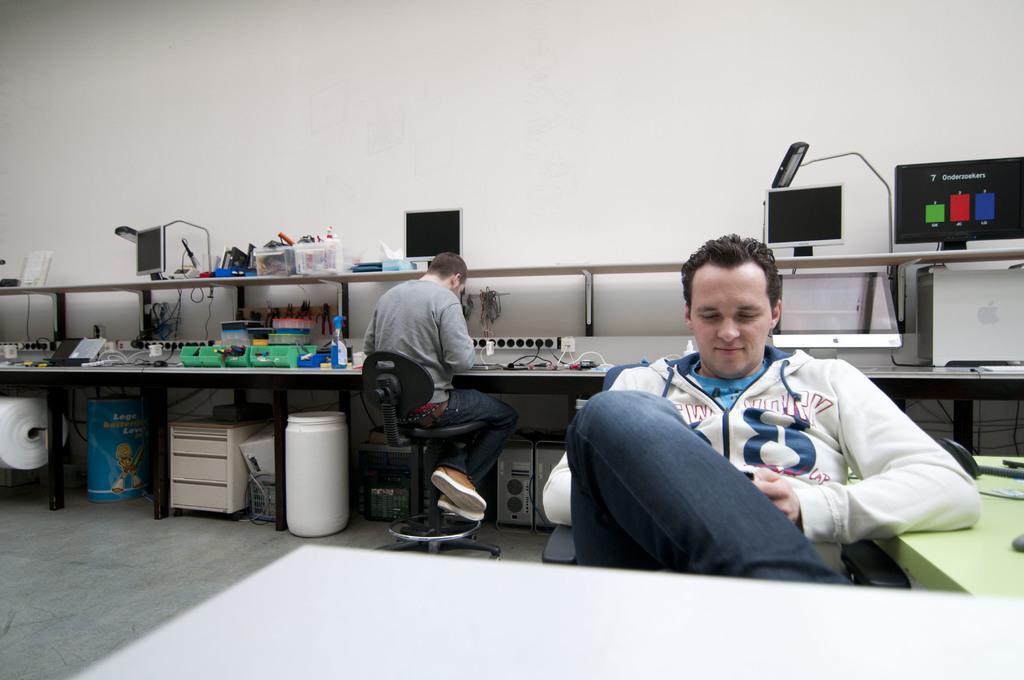Could you give a brief overview of what you see in this image? In this image we can see a two persons sitting on the chair. On the table there some machines. 